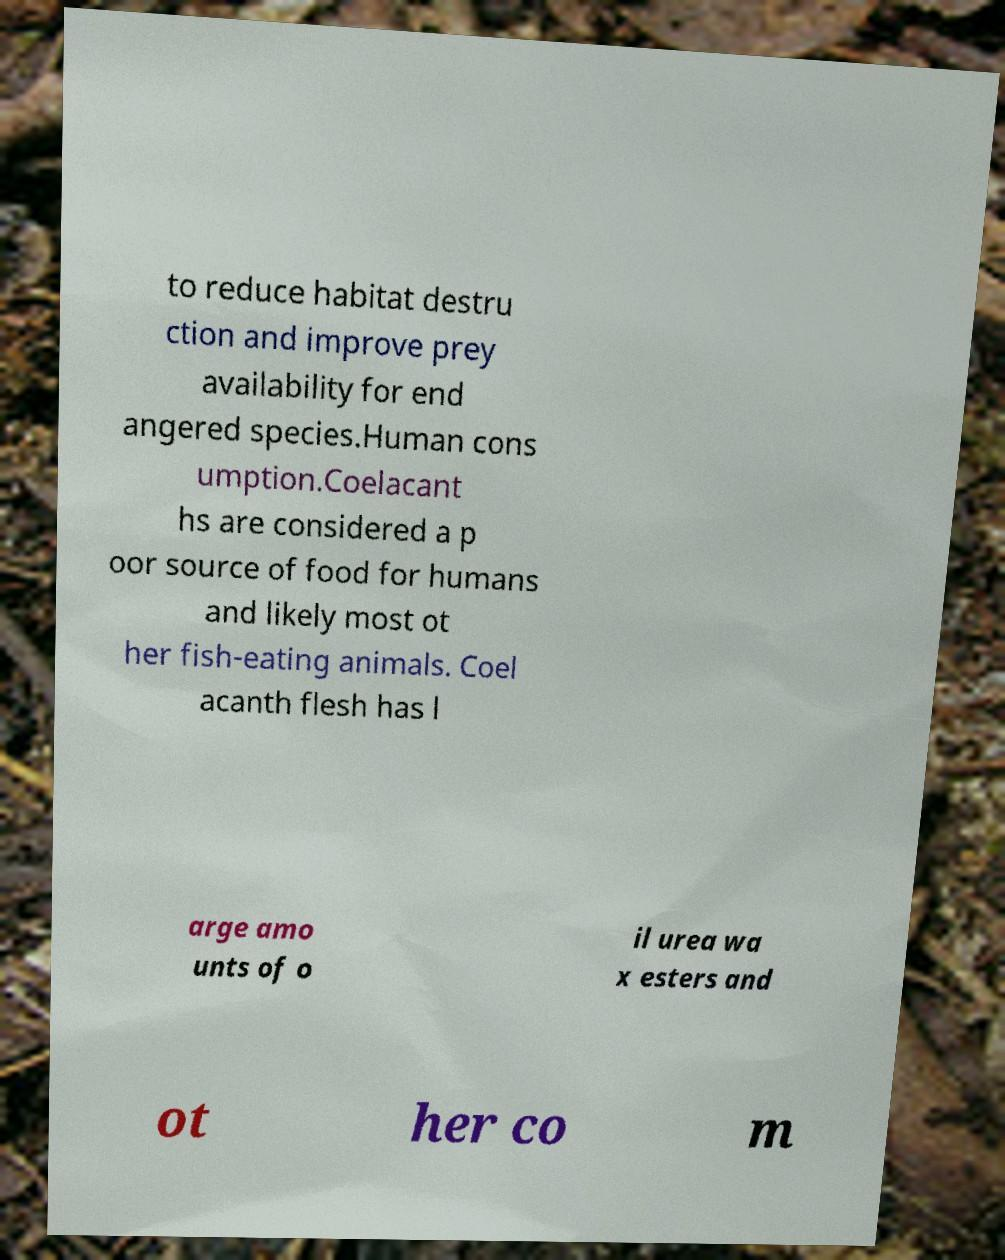Could you extract and type out the text from this image? to reduce habitat destru ction and improve prey availability for end angered species.Human cons umption.Coelacant hs are considered a p oor source of food for humans and likely most ot her fish-eating animals. Coel acanth flesh has l arge amo unts of o il urea wa x esters and ot her co m 